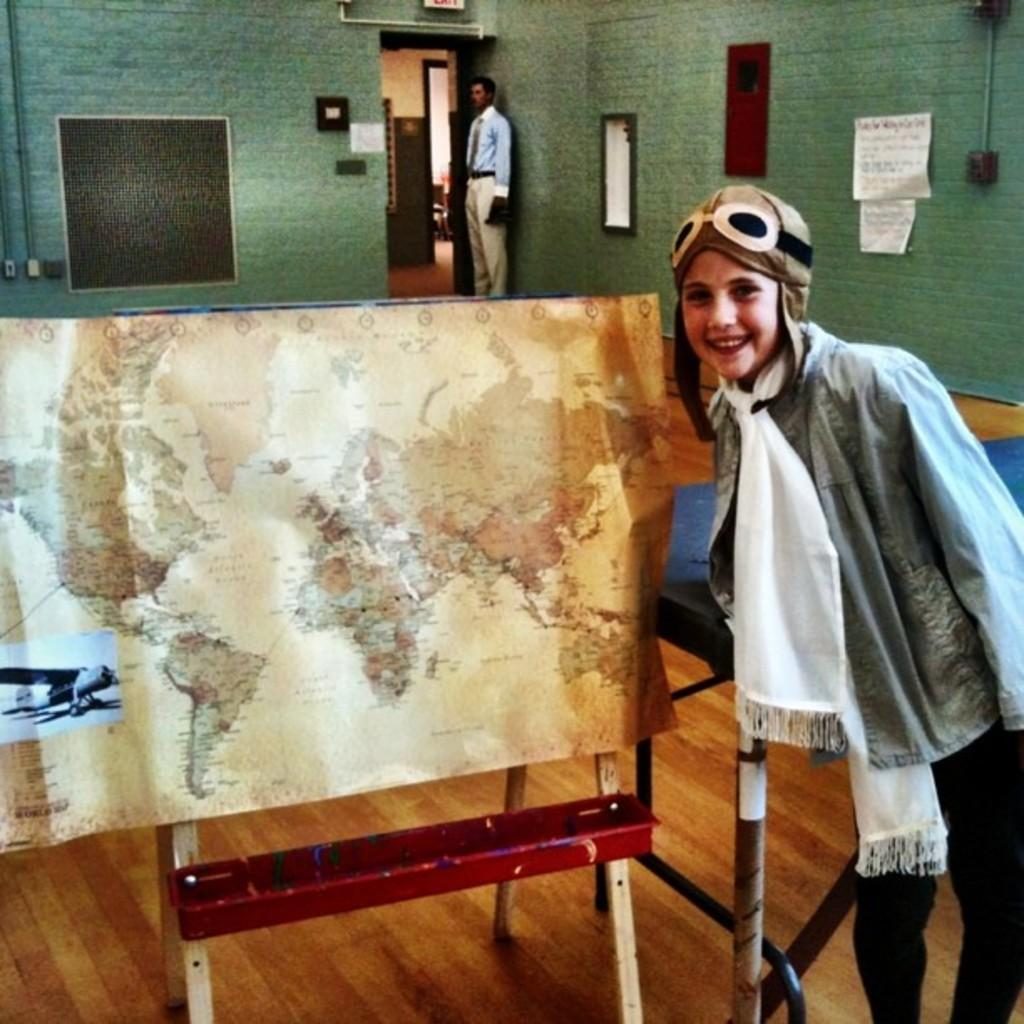What is the main object in the image? There is a map in the image. How is the map displayed? The map is on a stand. Can you describe the people in the image? There is a person standing near the map and another person standing in the image. What is present on the table in the image? There are papers on the table. What architectural feature is attached to the wall? There is a frame attached to the wall. What else can be seen in the image? There is a wall and pipes in the image. What is the fifth example of a fruit mentioned in the image? There are no examples of fruits mentioned in the image; it features a map, people, a table, papers, a frame, a wall, and pipes. 